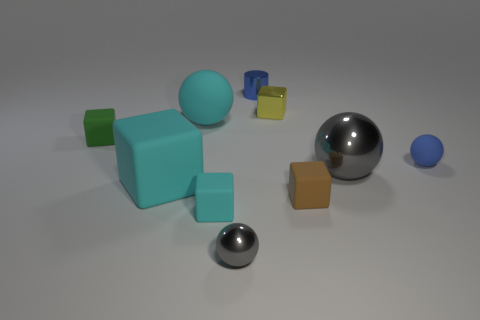Subtract 1 balls. How many balls are left? 3 Subtract all metal blocks. How many blocks are left? 4 Subtract all green blocks. How many blocks are left? 4 Subtract all gray blocks. Subtract all purple balls. How many blocks are left? 5 Subtract all spheres. How many objects are left? 6 Add 2 big yellow shiny spheres. How many big yellow shiny spheres exist? 2 Subtract 1 yellow blocks. How many objects are left? 9 Subtract all cyan rubber things. Subtract all small spheres. How many objects are left? 5 Add 6 tiny matte spheres. How many tiny matte spheres are left? 7 